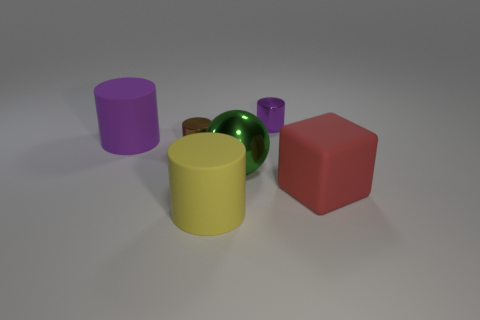Add 2 large metal things. How many objects exist? 8 Subtract all balls. How many objects are left? 5 Subtract all brown matte blocks. Subtract all large green objects. How many objects are left? 5 Add 2 metallic things. How many metallic things are left? 5 Add 5 big cyan matte things. How many big cyan matte things exist? 5 Subtract 1 green balls. How many objects are left? 5 